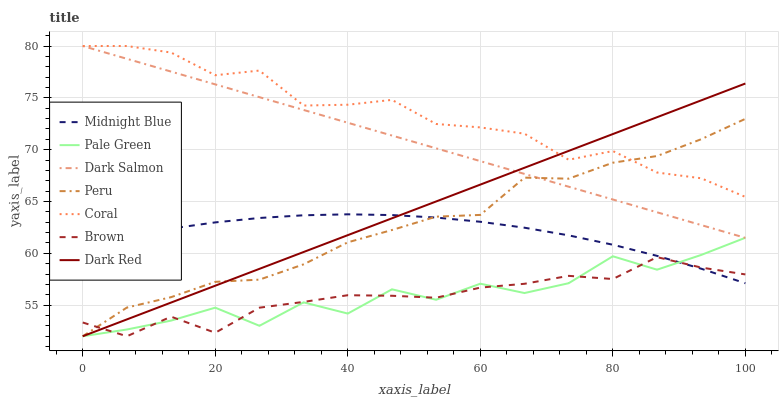Does Brown have the minimum area under the curve?
Answer yes or no. Yes. Does Coral have the maximum area under the curve?
Answer yes or no. Yes. Does Midnight Blue have the minimum area under the curve?
Answer yes or no. No. Does Midnight Blue have the maximum area under the curve?
Answer yes or no. No. Is Dark Salmon the smoothest?
Answer yes or no. Yes. Is Pale Green the roughest?
Answer yes or no. Yes. Is Midnight Blue the smoothest?
Answer yes or no. No. Is Midnight Blue the roughest?
Answer yes or no. No. Does Brown have the lowest value?
Answer yes or no. Yes. Does Midnight Blue have the lowest value?
Answer yes or no. No. Does Dark Salmon have the highest value?
Answer yes or no. Yes. Does Midnight Blue have the highest value?
Answer yes or no. No. Is Midnight Blue less than Coral?
Answer yes or no. Yes. Is Coral greater than Midnight Blue?
Answer yes or no. Yes. Does Coral intersect Peru?
Answer yes or no. Yes. Is Coral less than Peru?
Answer yes or no. No. Is Coral greater than Peru?
Answer yes or no. No. Does Midnight Blue intersect Coral?
Answer yes or no. No. 